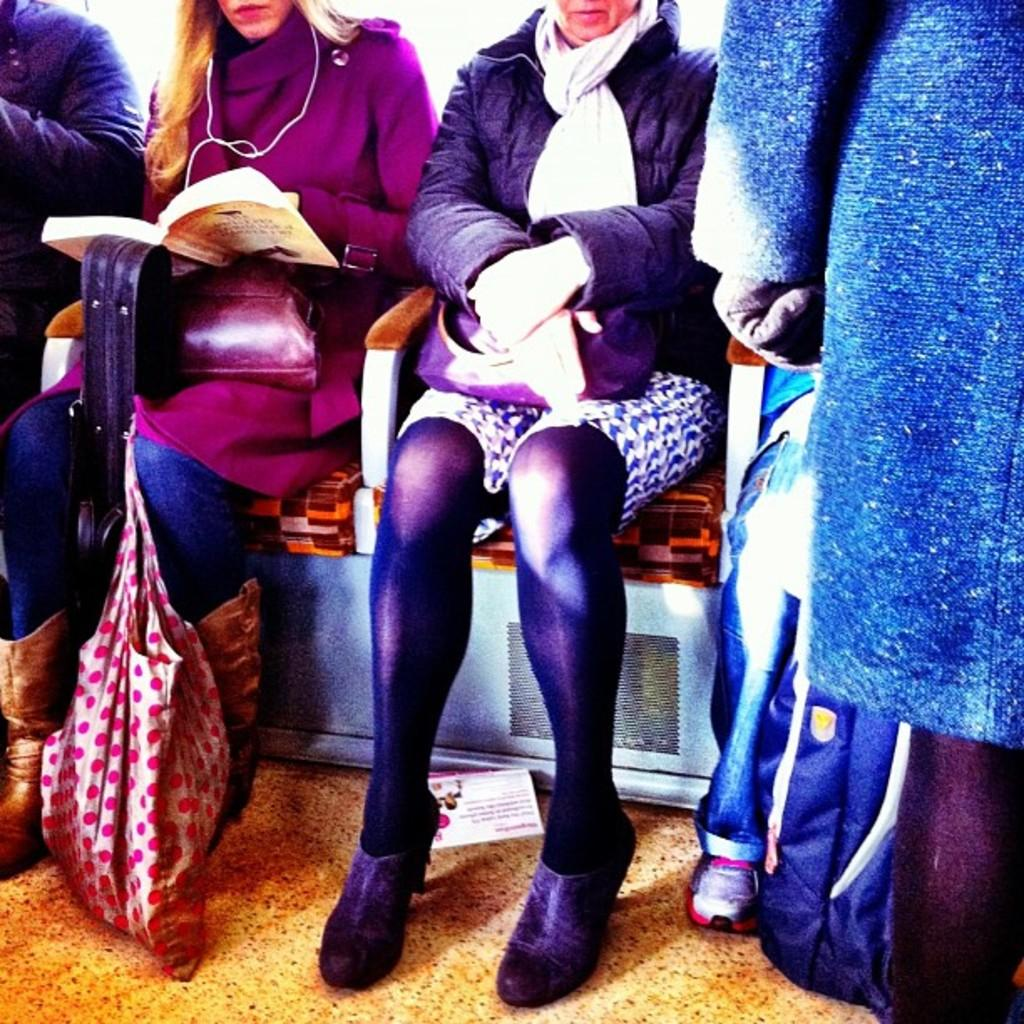What are the people in the image doing? The people in the image are sitting in chairs. What are some of the people holding? Some of the people are holding bags. What is the lady holding in the image? The lady is holding a book. What else can be seen on the floor in the image? There are bags on the floor. What shape is the sun in the image? There is no sun present in the image. How much money is visible in the image? There is no money visible in the image. 